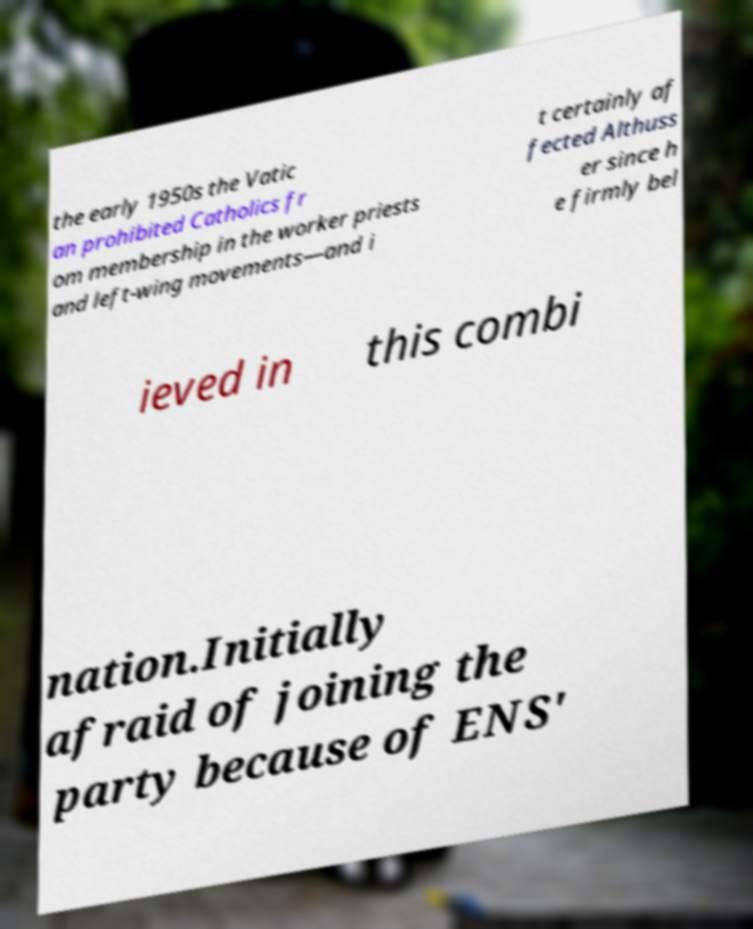I need the written content from this picture converted into text. Can you do that? the early 1950s the Vatic an prohibited Catholics fr om membership in the worker priests and left-wing movements—and i t certainly af fected Althuss er since h e firmly bel ieved in this combi nation.Initially afraid of joining the party because of ENS' 